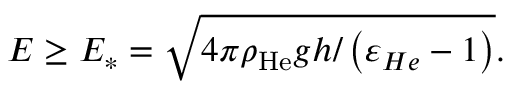<formula> <loc_0><loc_0><loc_500><loc_500>E \geq E _ { \ast } = \sqrt { 4 \pi \rho _ { H e } g h / \left ( \varepsilon _ { H e } - 1 \right ) } .</formula> 